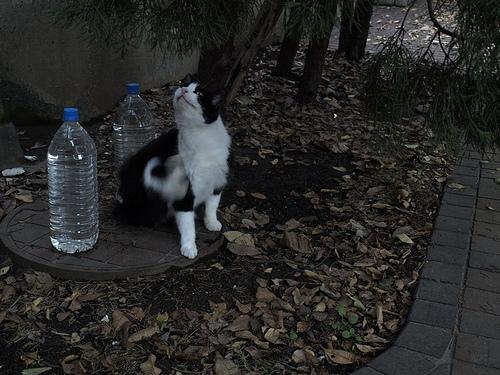What color is the cat?
Concise answer only. Black and white. Is the animal an adult?
Short answer required. Yes. Is it possible that this cat has fleas?
Answer briefly. Yes. How many pets are shown?
Concise answer only. 1. Is this cat fixated on an object above him?
Short answer required. Yes. How many cats?
Write a very short answer. 1. What would have to happen first before the cat could drink that water?
Keep it brief. Open bottle. 